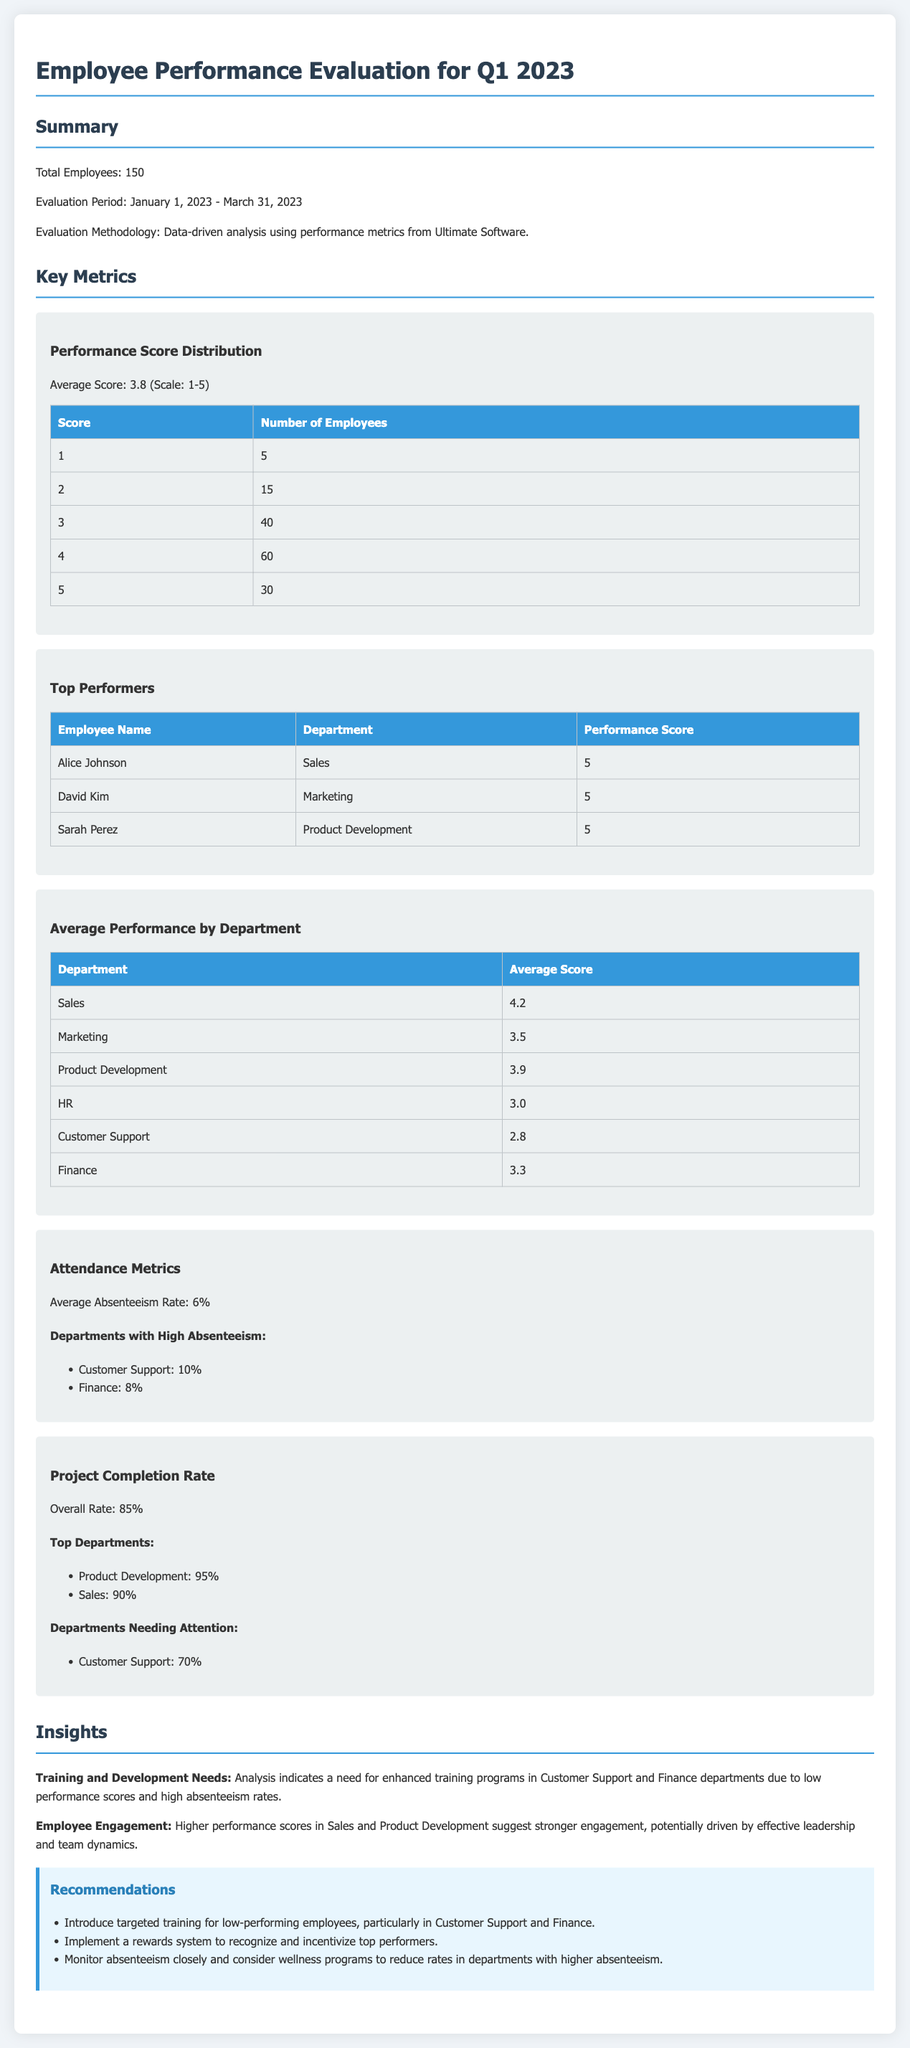what is the total number of employees? The total number of employees is directly stated in the summary section of the document.
Answer: 150 what was the average performance score? The average score is calculated based on the provided performance score distribution table.
Answer: 3.8 which department had the highest average performance score? The department with the highest average score is listed in the average performance by department table.
Answer: Sales how many employees received a performance score of 1? The number of employees who received a performance score of 1 is shown in the performance score distribution table.
Answer: 5 what is the average absenteeism rate? The average absenteeism rate is provided in the attendance metrics section of the document.
Answer: 6% which department showed the highest project completion rate? The department with the highest project completion rate can be found in the project completion rate section.
Answer: Product Development what is a key insight related to training needs? The insights section discusses specific training needs based on performance evaluation.
Answer: Enhanced training programs how many employees scored 5 in the performance evaluation? The number of employees who received a perfect score is included in the performance score distribution table.
Answer: 30 what is one of the recommendations for improving employee performance? The recommendations section outlines specific actions to improve performance based on findings.
Answer: Introduce targeted training 